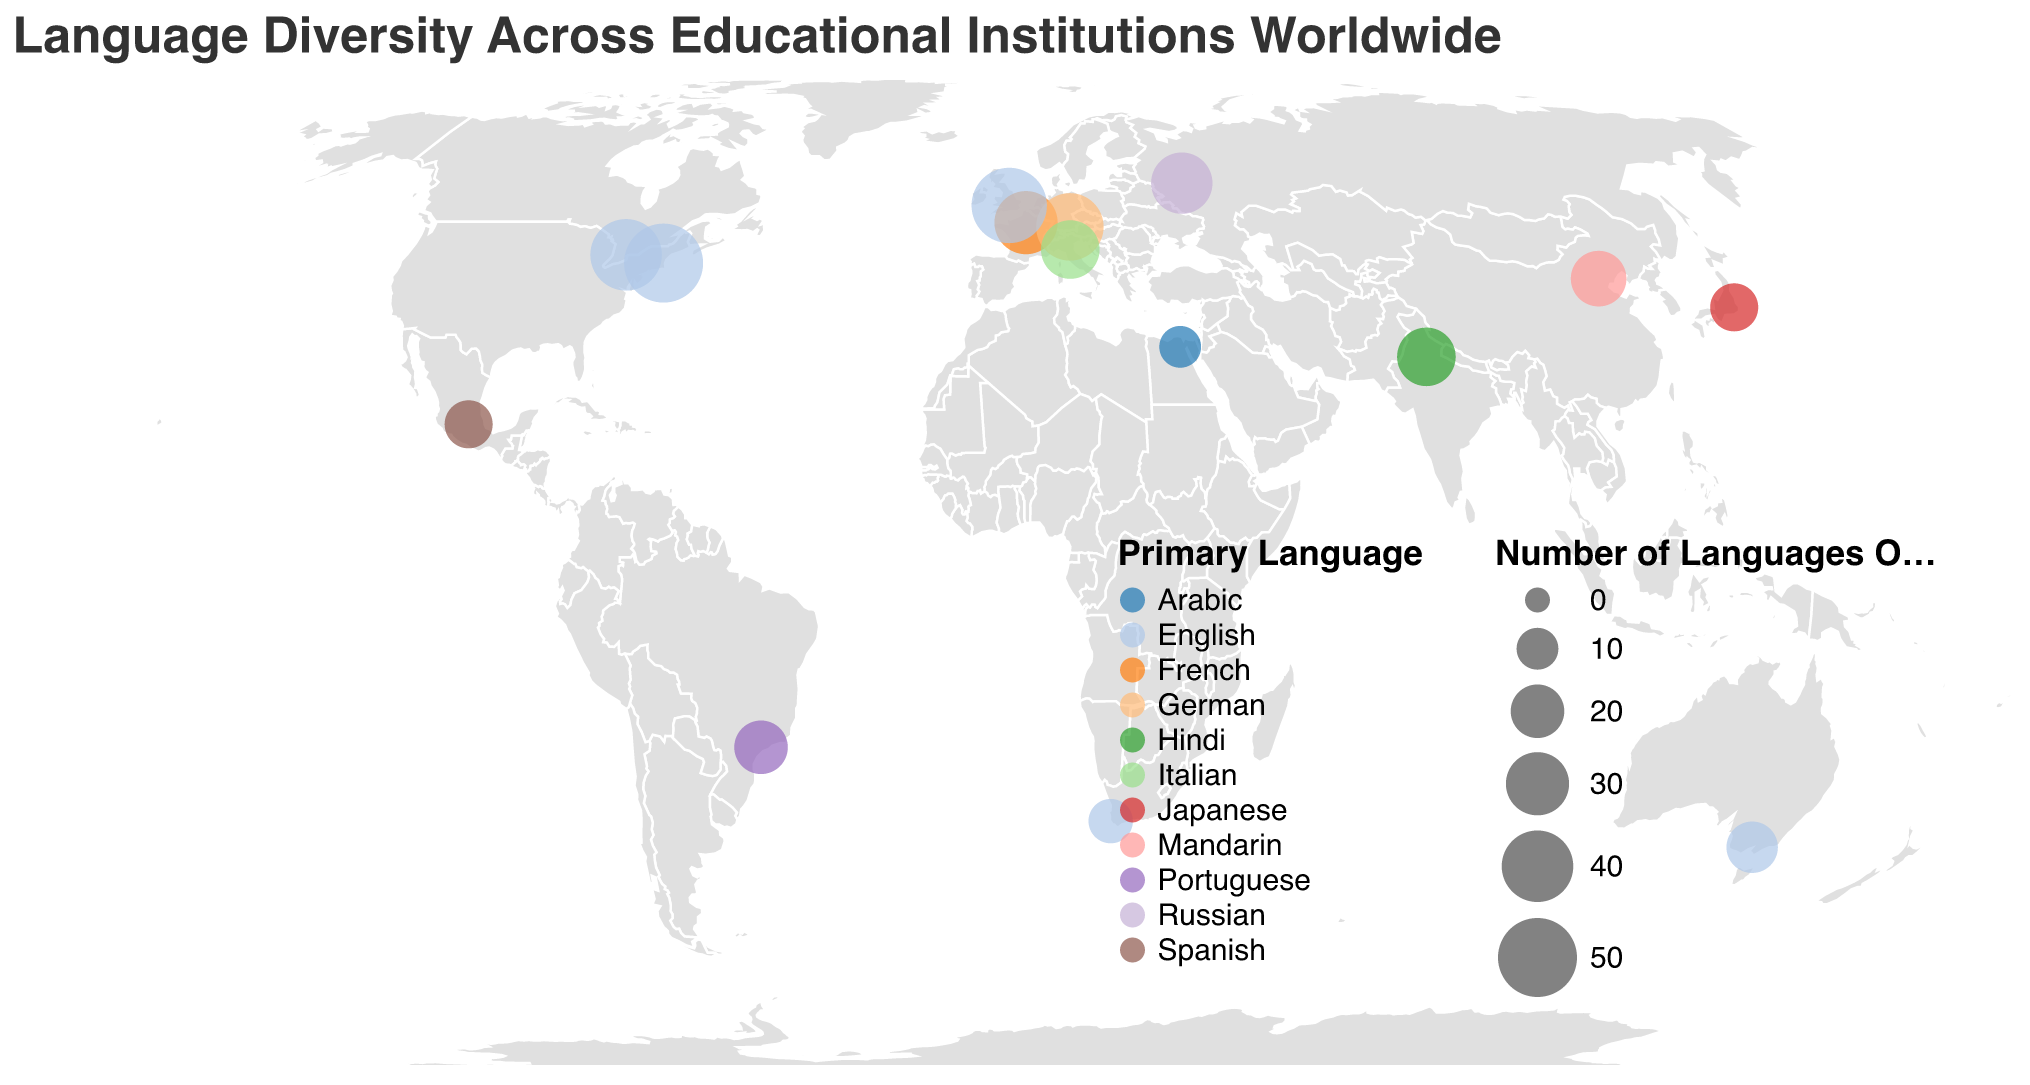How many institutions are represented in the figure? Count the number of unique data points represented as circles on the map.
Answer: 15 Which institution offers the most number of languages? Identify the circle with the largest size, corresponding to the highest 'Number_of_Languages_Offered'.
Answer: Harvard University What is the primary language most often used among the listed institutions? Look at the color legend and count the predominant color representing the primary language.
Answer: English How does the number of languages offered by University of Oxford compare to University of Tokyo? Find the sizes of the circles representing these institutions and compare their values.
Answer: University of Oxford has 45 languages, University of Tokyo has 15 languages. Oxford offers 30 more languages Which country has the smallest number of languages offered across its institution? Locate the smallest circle on the map and identify the corresponding country.
Answer: Egypt (Cairo University) What is the primary language of institutions located in countries on the Southern Hemisphere? Identify the countries in the Southern Hemisphere and examine the colors representing their primary languages. Southern Hemisphere countries include Brazil, South Africa, and Australia.
Answer: Portuguese, English, English How many institutions have more than 30 languages offered? Count the number of circles with sizes representing more than 30 languages.
Answer: 5 (Harvard, University of Oxford, Ludwig Maximilian University of Munich, University of Toronto, Sorbonne University) Which institution represents universities in the Middle East? Look at the geographic location corresponding to the longitude and latitude for the Middle East.
Answer: Cairo University How many institutions offer Italian as a secondary language? Identify the institutions that list Italian in their secondary languages section.
Answer: 4 (Sorbonne University, Ludwig Maximilian University of Munich, University of Bologna, University of Oxford) What is the average number of languages offered by institutions in North America? Identify the institutions in North America and calculate the average number of languages offered by summing their languages and dividing by the number of institutions. North America includes Harvard University and University of Toronto. (50 + 40) / 2
Answer: 45 How many primary languages are presented in the chart? Count the unique colors in the legend representing primary languages.
Answer: 10 